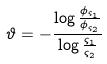Convert formula to latex. <formula><loc_0><loc_0><loc_500><loc_500>\vartheta = - \frac { \log \frac { \phi _ { \varsigma _ { 1 } } } { \phi _ { \varsigma _ { 2 } } } } { \log \frac { \varsigma _ { 1 } } { \varsigma _ { 2 } } }</formula> 